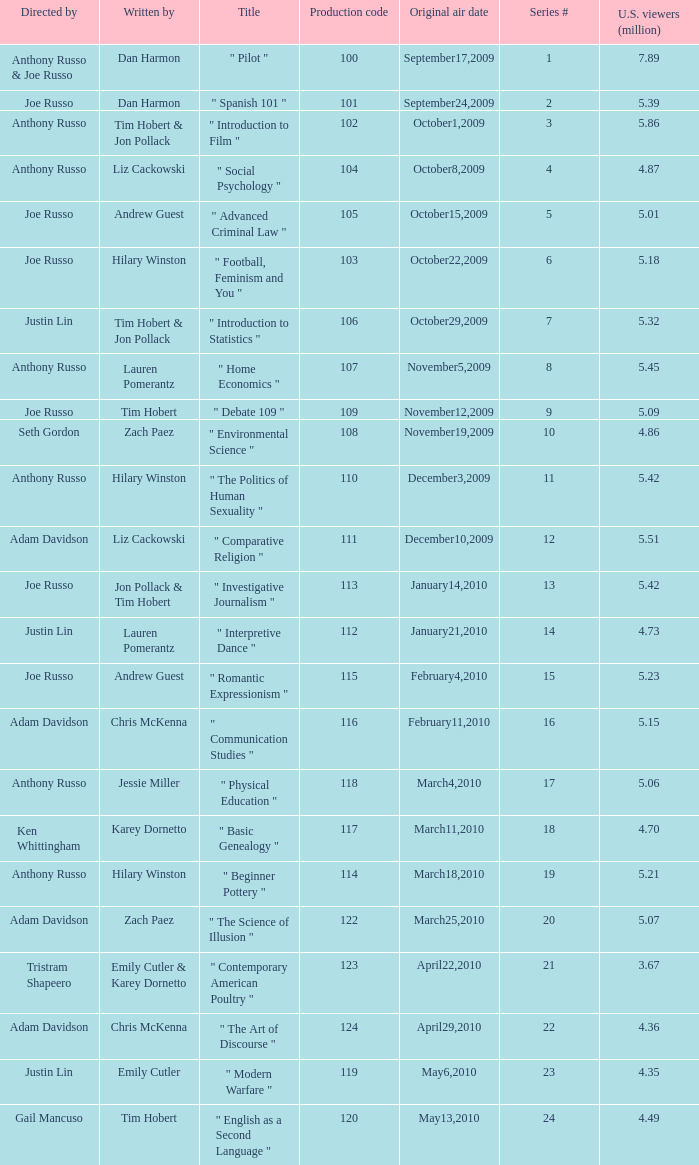What is the original air date when the u.s. viewers in millions was 5.39? September24,2009. 